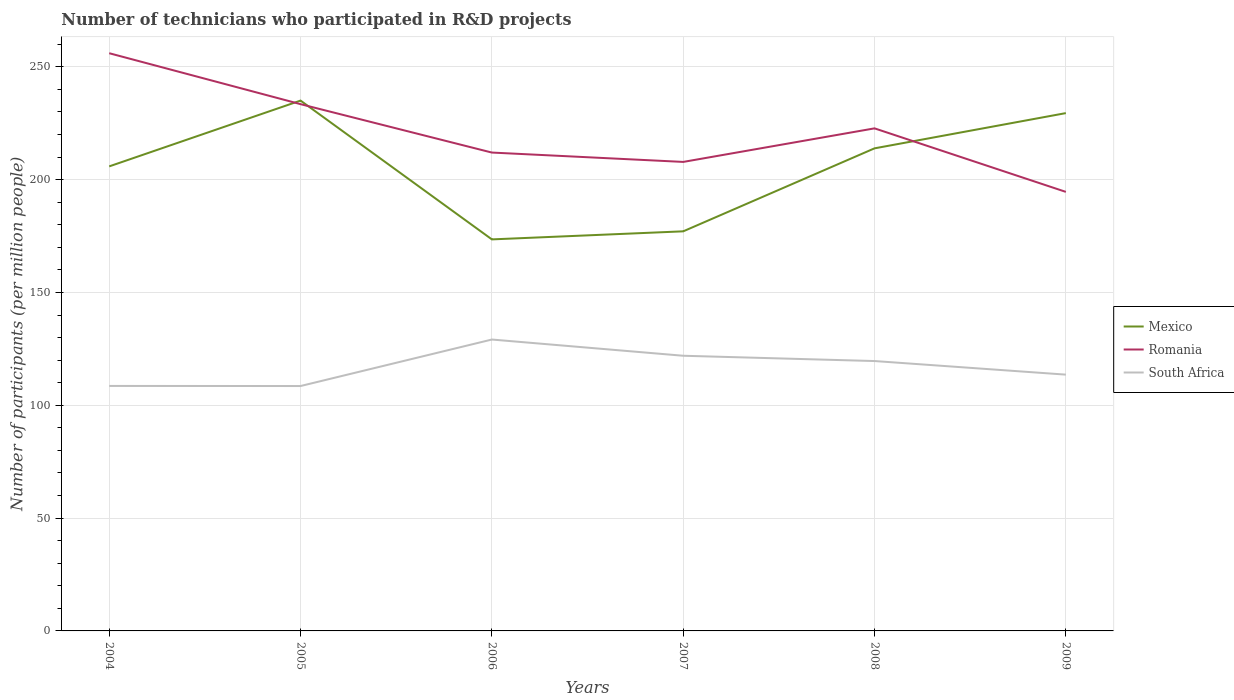Across all years, what is the maximum number of technicians who participated in R&D projects in South Africa?
Provide a succinct answer. 108.54. In which year was the number of technicians who participated in R&D projects in Mexico maximum?
Your answer should be very brief. 2006. What is the total number of technicians who participated in R&D projects in South Africa in the graph?
Provide a short and direct response. -11.07. What is the difference between the highest and the second highest number of technicians who participated in R&D projects in South Africa?
Give a very brief answer. 20.6. What is the difference between the highest and the lowest number of technicians who participated in R&D projects in Romania?
Make the answer very short. 3. How many lines are there?
Give a very brief answer. 3. How many years are there in the graph?
Provide a succinct answer. 6. Are the values on the major ticks of Y-axis written in scientific E-notation?
Provide a succinct answer. No. What is the title of the graph?
Make the answer very short. Number of technicians who participated in R&D projects. What is the label or title of the Y-axis?
Your response must be concise. Number of participants (per million people). What is the Number of participants (per million people) in Mexico in 2004?
Offer a terse response. 205.89. What is the Number of participants (per million people) in Romania in 2004?
Your answer should be very brief. 256.04. What is the Number of participants (per million people) of South Africa in 2004?
Your response must be concise. 108.58. What is the Number of participants (per million people) of Mexico in 2005?
Your response must be concise. 235.05. What is the Number of participants (per million people) of Romania in 2005?
Your answer should be very brief. 233.47. What is the Number of participants (per million people) in South Africa in 2005?
Your response must be concise. 108.54. What is the Number of participants (per million people) of Mexico in 2006?
Your answer should be compact. 173.53. What is the Number of participants (per million people) in Romania in 2006?
Keep it short and to the point. 212.02. What is the Number of participants (per million people) in South Africa in 2006?
Give a very brief answer. 129.14. What is the Number of participants (per million people) of Mexico in 2007?
Provide a succinct answer. 177.1. What is the Number of participants (per million people) in Romania in 2007?
Provide a short and direct response. 207.87. What is the Number of participants (per million people) of South Africa in 2007?
Your answer should be compact. 121.96. What is the Number of participants (per million people) in Mexico in 2008?
Your answer should be compact. 213.89. What is the Number of participants (per million people) of Romania in 2008?
Keep it short and to the point. 222.74. What is the Number of participants (per million people) in South Africa in 2008?
Keep it short and to the point. 119.61. What is the Number of participants (per million people) in Mexico in 2009?
Make the answer very short. 229.5. What is the Number of participants (per million people) in Romania in 2009?
Offer a terse response. 194.59. What is the Number of participants (per million people) of South Africa in 2009?
Give a very brief answer. 113.59. Across all years, what is the maximum Number of participants (per million people) of Mexico?
Offer a terse response. 235.05. Across all years, what is the maximum Number of participants (per million people) in Romania?
Ensure brevity in your answer.  256.04. Across all years, what is the maximum Number of participants (per million people) in South Africa?
Your answer should be very brief. 129.14. Across all years, what is the minimum Number of participants (per million people) of Mexico?
Your response must be concise. 173.53. Across all years, what is the minimum Number of participants (per million people) in Romania?
Your answer should be compact. 194.59. Across all years, what is the minimum Number of participants (per million people) in South Africa?
Offer a very short reply. 108.54. What is the total Number of participants (per million people) in Mexico in the graph?
Your answer should be very brief. 1234.95. What is the total Number of participants (per million people) of Romania in the graph?
Your response must be concise. 1326.72. What is the total Number of participants (per million people) in South Africa in the graph?
Your response must be concise. 701.43. What is the difference between the Number of participants (per million people) in Mexico in 2004 and that in 2005?
Your answer should be compact. -29.16. What is the difference between the Number of participants (per million people) in Romania in 2004 and that in 2005?
Your answer should be very brief. 22.58. What is the difference between the Number of participants (per million people) of South Africa in 2004 and that in 2005?
Keep it short and to the point. 0.04. What is the difference between the Number of participants (per million people) of Mexico in 2004 and that in 2006?
Provide a succinct answer. 32.36. What is the difference between the Number of participants (per million people) of Romania in 2004 and that in 2006?
Your answer should be very brief. 44.03. What is the difference between the Number of participants (per million people) in South Africa in 2004 and that in 2006?
Offer a terse response. -20.56. What is the difference between the Number of participants (per million people) in Mexico in 2004 and that in 2007?
Your response must be concise. 28.79. What is the difference between the Number of participants (per million people) of Romania in 2004 and that in 2007?
Ensure brevity in your answer.  48.18. What is the difference between the Number of participants (per million people) of South Africa in 2004 and that in 2007?
Your response must be concise. -13.38. What is the difference between the Number of participants (per million people) in Mexico in 2004 and that in 2008?
Your response must be concise. -8. What is the difference between the Number of participants (per million people) in Romania in 2004 and that in 2008?
Keep it short and to the point. 33.3. What is the difference between the Number of participants (per million people) of South Africa in 2004 and that in 2008?
Keep it short and to the point. -11.03. What is the difference between the Number of participants (per million people) of Mexico in 2004 and that in 2009?
Give a very brief answer. -23.61. What is the difference between the Number of participants (per million people) in Romania in 2004 and that in 2009?
Provide a succinct answer. 61.46. What is the difference between the Number of participants (per million people) of South Africa in 2004 and that in 2009?
Make the answer very short. -5.01. What is the difference between the Number of participants (per million people) of Mexico in 2005 and that in 2006?
Keep it short and to the point. 61.52. What is the difference between the Number of participants (per million people) of Romania in 2005 and that in 2006?
Offer a terse response. 21.45. What is the difference between the Number of participants (per million people) of South Africa in 2005 and that in 2006?
Ensure brevity in your answer.  -20.6. What is the difference between the Number of participants (per million people) in Mexico in 2005 and that in 2007?
Your response must be concise. 57.95. What is the difference between the Number of participants (per million people) in Romania in 2005 and that in 2007?
Your response must be concise. 25.6. What is the difference between the Number of participants (per million people) of South Africa in 2005 and that in 2007?
Your answer should be very brief. -13.42. What is the difference between the Number of participants (per million people) in Mexico in 2005 and that in 2008?
Offer a terse response. 21.16. What is the difference between the Number of participants (per million people) in Romania in 2005 and that in 2008?
Make the answer very short. 10.73. What is the difference between the Number of participants (per million people) in South Africa in 2005 and that in 2008?
Provide a short and direct response. -11.07. What is the difference between the Number of participants (per million people) of Mexico in 2005 and that in 2009?
Give a very brief answer. 5.55. What is the difference between the Number of participants (per million people) of Romania in 2005 and that in 2009?
Provide a succinct answer. 38.88. What is the difference between the Number of participants (per million people) in South Africa in 2005 and that in 2009?
Provide a succinct answer. -5.05. What is the difference between the Number of participants (per million people) of Mexico in 2006 and that in 2007?
Your answer should be very brief. -3.57. What is the difference between the Number of participants (per million people) in Romania in 2006 and that in 2007?
Provide a succinct answer. 4.15. What is the difference between the Number of participants (per million people) in South Africa in 2006 and that in 2007?
Your answer should be compact. 7.19. What is the difference between the Number of participants (per million people) of Mexico in 2006 and that in 2008?
Offer a terse response. -40.36. What is the difference between the Number of participants (per million people) of Romania in 2006 and that in 2008?
Ensure brevity in your answer.  -10.72. What is the difference between the Number of participants (per million people) in South Africa in 2006 and that in 2008?
Give a very brief answer. 9.53. What is the difference between the Number of participants (per million people) of Mexico in 2006 and that in 2009?
Give a very brief answer. -55.97. What is the difference between the Number of participants (per million people) of Romania in 2006 and that in 2009?
Ensure brevity in your answer.  17.43. What is the difference between the Number of participants (per million people) of South Africa in 2006 and that in 2009?
Offer a terse response. 15.55. What is the difference between the Number of participants (per million people) of Mexico in 2007 and that in 2008?
Your response must be concise. -36.79. What is the difference between the Number of participants (per million people) of Romania in 2007 and that in 2008?
Offer a terse response. -14.87. What is the difference between the Number of participants (per million people) in South Africa in 2007 and that in 2008?
Offer a terse response. 2.34. What is the difference between the Number of participants (per million people) in Mexico in 2007 and that in 2009?
Make the answer very short. -52.4. What is the difference between the Number of participants (per million people) of Romania in 2007 and that in 2009?
Ensure brevity in your answer.  13.28. What is the difference between the Number of participants (per million people) in South Africa in 2007 and that in 2009?
Provide a succinct answer. 8.37. What is the difference between the Number of participants (per million people) of Mexico in 2008 and that in 2009?
Offer a very short reply. -15.61. What is the difference between the Number of participants (per million people) of Romania in 2008 and that in 2009?
Offer a very short reply. 28.15. What is the difference between the Number of participants (per million people) of South Africa in 2008 and that in 2009?
Offer a very short reply. 6.02. What is the difference between the Number of participants (per million people) in Mexico in 2004 and the Number of participants (per million people) in Romania in 2005?
Offer a very short reply. -27.58. What is the difference between the Number of participants (per million people) of Mexico in 2004 and the Number of participants (per million people) of South Africa in 2005?
Give a very brief answer. 97.35. What is the difference between the Number of participants (per million people) of Romania in 2004 and the Number of participants (per million people) of South Africa in 2005?
Keep it short and to the point. 147.5. What is the difference between the Number of participants (per million people) in Mexico in 2004 and the Number of participants (per million people) in Romania in 2006?
Your response must be concise. -6.13. What is the difference between the Number of participants (per million people) in Mexico in 2004 and the Number of participants (per million people) in South Africa in 2006?
Ensure brevity in your answer.  76.74. What is the difference between the Number of participants (per million people) in Romania in 2004 and the Number of participants (per million people) in South Africa in 2006?
Make the answer very short. 126.9. What is the difference between the Number of participants (per million people) of Mexico in 2004 and the Number of participants (per million people) of Romania in 2007?
Keep it short and to the point. -1.98. What is the difference between the Number of participants (per million people) of Mexico in 2004 and the Number of participants (per million people) of South Africa in 2007?
Offer a terse response. 83.93. What is the difference between the Number of participants (per million people) of Romania in 2004 and the Number of participants (per million people) of South Africa in 2007?
Give a very brief answer. 134.09. What is the difference between the Number of participants (per million people) in Mexico in 2004 and the Number of participants (per million people) in Romania in 2008?
Ensure brevity in your answer.  -16.85. What is the difference between the Number of participants (per million people) of Mexico in 2004 and the Number of participants (per million people) of South Africa in 2008?
Offer a terse response. 86.27. What is the difference between the Number of participants (per million people) in Romania in 2004 and the Number of participants (per million people) in South Africa in 2008?
Provide a short and direct response. 136.43. What is the difference between the Number of participants (per million people) of Mexico in 2004 and the Number of participants (per million people) of Romania in 2009?
Offer a very short reply. 11.3. What is the difference between the Number of participants (per million people) of Mexico in 2004 and the Number of participants (per million people) of South Africa in 2009?
Make the answer very short. 92.3. What is the difference between the Number of participants (per million people) in Romania in 2004 and the Number of participants (per million people) in South Africa in 2009?
Ensure brevity in your answer.  142.45. What is the difference between the Number of participants (per million people) in Mexico in 2005 and the Number of participants (per million people) in Romania in 2006?
Provide a short and direct response. 23.03. What is the difference between the Number of participants (per million people) in Mexico in 2005 and the Number of participants (per million people) in South Africa in 2006?
Give a very brief answer. 105.9. What is the difference between the Number of participants (per million people) of Romania in 2005 and the Number of participants (per million people) of South Africa in 2006?
Give a very brief answer. 104.32. What is the difference between the Number of participants (per million people) of Mexico in 2005 and the Number of participants (per million people) of Romania in 2007?
Make the answer very short. 27.18. What is the difference between the Number of participants (per million people) of Mexico in 2005 and the Number of participants (per million people) of South Africa in 2007?
Your answer should be compact. 113.09. What is the difference between the Number of participants (per million people) of Romania in 2005 and the Number of participants (per million people) of South Africa in 2007?
Your answer should be very brief. 111.51. What is the difference between the Number of participants (per million people) of Mexico in 2005 and the Number of participants (per million people) of Romania in 2008?
Provide a short and direct response. 12.31. What is the difference between the Number of participants (per million people) of Mexico in 2005 and the Number of participants (per million people) of South Africa in 2008?
Provide a succinct answer. 115.43. What is the difference between the Number of participants (per million people) in Romania in 2005 and the Number of participants (per million people) in South Africa in 2008?
Your answer should be very brief. 113.85. What is the difference between the Number of participants (per million people) of Mexico in 2005 and the Number of participants (per million people) of Romania in 2009?
Make the answer very short. 40.46. What is the difference between the Number of participants (per million people) of Mexico in 2005 and the Number of participants (per million people) of South Africa in 2009?
Give a very brief answer. 121.46. What is the difference between the Number of participants (per million people) in Romania in 2005 and the Number of participants (per million people) in South Africa in 2009?
Make the answer very short. 119.88. What is the difference between the Number of participants (per million people) of Mexico in 2006 and the Number of participants (per million people) of Romania in 2007?
Keep it short and to the point. -34.34. What is the difference between the Number of participants (per million people) of Mexico in 2006 and the Number of participants (per million people) of South Africa in 2007?
Offer a very short reply. 51.57. What is the difference between the Number of participants (per million people) in Romania in 2006 and the Number of participants (per million people) in South Africa in 2007?
Your answer should be very brief. 90.06. What is the difference between the Number of participants (per million people) of Mexico in 2006 and the Number of participants (per million people) of Romania in 2008?
Make the answer very short. -49.21. What is the difference between the Number of participants (per million people) of Mexico in 2006 and the Number of participants (per million people) of South Africa in 2008?
Ensure brevity in your answer.  53.91. What is the difference between the Number of participants (per million people) of Romania in 2006 and the Number of participants (per million people) of South Africa in 2008?
Your answer should be compact. 92.4. What is the difference between the Number of participants (per million people) in Mexico in 2006 and the Number of participants (per million people) in Romania in 2009?
Offer a terse response. -21.06. What is the difference between the Number of participants (per million people) of Mexico in 2006 and the Number of participants (per million people) of South Africa in 2009?
Make the answer very short. 59.94. What is the difference between the Number of participants (per million people) of Romania in 2006 and the Number of participants (per million people) of South Africa in 2009?
Make the answer very short. 98.43. What is the difference between the Number of participants (per million people) in Mexico in 2007 and the Number of participants (per million people) in Romania in 2008?
Your answer should be compact. -45.64. What is the difference between the Number of participants (per million people) of Mexico in 2007 and the Number of participants (per million people) of South Africa in 2008?
Provide a short and direct response. 57.49. What is the difference between the Number of participants (per million people) in Romania in 2007 and the Number of participants (per million people) in South Africa in 2008?
Offer a very short reply. 88.25. What is the difference between the Number of participants (per million people) in Mexico in 2007 and the Number of participants (per million people) in Romania in 2009?
Provide a succinct answer. -17.49. What is the difference between the Number of participants (per million people) in Mexico in 2007 and the Number of participants (per million people) in South Africa in 2009?
Keep it short and to the point. 63.51. What is the difference between the Number of participants (per million people) of Romania in 2007 and the Number of participants (per million people) of South Africa in 2009?
Provide a succinct answer. 94.28. What is the difference between the Number of participants (per million people) in Mexico in 2008 and the Number of participants (per million people) in Romania in 2009?
Your answer should be very brief. 19.3. What is the difference between the Number of participants (per million people) in Mexico in 2008 and the Number of participants (per million people) in South Africa in 2009?
Give a very brief answer. 100.3. What is the difference between the Number of participants (per million people) in Romania in 2008 and the Number of participants (per million people) in South Africa in 2009?
Make the answer very short. 109.15. What is the average Number of participants (per million people) of Mexico per year?
Give a very brief answer. 205.82. What is the average Number of participants (per million people) in Romania per year?
Make the answer very short. 221.12. What is the average Number of participants (per million people) in South Africa per year?
Offer a very short reply. 116.9. In the year 2004, what is the difference between the Number of participants (per million people) of Mexico and Number of participants (per million people) of Romania?
Your answer should be very brief. -50.16. In the year 2004, what is the difference between the Number of participants (per million people) of Mexico and Number of participants (per million people) of South Africa?
Ensure brevity in your answer.  97.31. In the year 2004, what is the difference between the Number of participants (per million people) of Romania and Number of participants (per million people) of South Africa?
Provide a succinct answer. 147.46. In the year 2005, what is the difference between the Number of participants (per million people) in Mexico and Number of participants (per million people) in Romania?
Your answer should be compact. 1.58. In the year 2005, what is the difference between the Number of participants (per million people) of Mexico and Number of participants (per million people) of South Africa?
Offer a terse response. 126.51. In the year 2005, what is the difference between the Number of participants (per million people) in Romania and Number of participants (per million people) in South Africa?
Provide a short and direct response. 124.93. In the year 2006, what is the difference between the Number of participants (per million people) in Mexico and Number of participants (per million people) in Romania?
Your answer should be very brief. -38.49. In the year 2006, what is the difference between the Number of participants (per million people) of Mexico and Number of participants (per million people) of South Africa?
Ensure brevity in your answer.  44.38. In the year 2006, what is the difference between the Number of participants (per million people) of Romania and Number of participants (per million people) of South Africa?
Provide a short and direct response. 82.87. In the year 2007, what is the difference between the Number of participants (per million people) in Mexico and Number of participants (per million people) in Romania?
Make the answer very short. -30.77. In the year 2007, what is the difference between the Number of participants (per million people) in Mexico and Number of participants (per million people) in South Africa?
Your answer should be very brief. 55.14. In the year 2007, what is the difference between the Number of participants (per million people) in Romania and Number of participants (per million people) in South Africa?
Give a very brief answer. 85.91. In the year 2008, what is the difference between the Number of participants (per million people) in Mexico and Number of participants (per million people) in Romania?
Provide a short and direct response. -8.85. In the year 2008, what is the difference between the Number of participants (per million people) of Mexico and Number of participants (per million people) of South Africa?
Provide a succinct answer. 94.27. In the year 2008, what is the difference between the Number of participants (per million people) in Romania and Number of participants (per million people) in South Africa?
Provide a short and direct response. 103.13. In the year 2009, what is the difference between the Number of participants (per million people) of Mexico and Number of participants (per million people) of Romania?
Provide a succinct answer. 34.91. In the year 2009, what is the difference between the Number of participants (per million people) in Mexico and Number of participants (per million people) in South Africa?
Keep it short and to the point. 115.91. In the year 2009, what is the difference between the Number of participants (per million people) of Romania and Number of participants (per million people) of South Africa?
Provide a succinct answer. 81. What is the ratio of the Number of participants (per million people) of Mexico in 2004 to that in 2005?
Offer a very short reply. 0.88. What is the ratio of the Number of participants (per million people) in Romania in 2004 to that in 2005?
Provide a short and direct response. 1.1. What is the ratio of the Number of participants (per million people) of South Africa in 2004 to that in 2005?
Provide a succinct answer. 1. What is the ratio of the Number of participants (per million people) in Mexico in 2004 to that in 2006?
Offer a terse response. 1.19. What is the ratio of the Number of participants (per million people) of Romania in 2004 to that in 2006?
Provide a succinct answer. 1.21. What is the ratio of the Number of participants (per million people) of South Africa in 2004 to that in 2006?
Give a very brief answer. 0.84. What is the ratio of the Number of participants (per million people) of Mexico in 2004 to that in 2007?
Make the answer very short. 1.16. What is the ratio of the Number of participants (per million people) in Romania in 2004 to that in 2007?
Provide a short and direct response. 1.23. What is the ratio of the Number of participants (per million people) of South Africa in 2004 to that in 2007?
Offer a very short reply. 0.89. What is the ratio of the Number of participants (per million people) of Mexico in 2004 to that in 2008?
Offer a very short reply. 0.96. What is the ratio of the Number of participants (per million people) of Romania in 2004 to that in 2008?
Your response must be concise. 1.15. What is the ratio of the Number of participants (per million people) in South Africa in 2004 to that in 2008?
Your answer should be very brief. 0.91. What is the ratio of the Number of participants (per million people) in Mexico in 2004 to that in 2009?
Your answer should be compact. 0.9. What is the ratio of the Number of participants (per million people) in Romania in 2004 to that in 2009?
Your answer should be compact. 1.32. What is the ratio of the Number of participants (per million people) in South Africa in 2004 to that in 2009?
Your answer should be compact. 0.96. What is the ratio of the Number of participants (per million people) in Mexico in 2005 to that in 2006?
Your answer should be very brief. 1.35. What is the ratio of the Number of participants (per million people) of Romania in 2005 to that in 2006?
Ensure brevity in your answer.  1.1. What is the ratio of the Number of participants (per million people) in South Africa in 2005 to that in 2006?
Provide a short and direct response. 0.84. What is the ratio of the Number of participants (per million people) in Mexico in 2005 to that in 2007?
Make the answer very short. 1.33. What is the ratio of the Number of participants (per million people) of Romania in 2005 to that in 2007?
Your answer should be very brief. 1.12. What is the ratio of the Number of participants (per million people) in South Africa in 2005 to that in 2007?
Offer a very short reply. 0.89. What is the ratio of the Number of participants (per million people) of Mexico in 2005 to that in 2008?
Offer a terse response. 1.1. What is the ratio of the Number of participants (per million people) of Romania in 2005 to that in 2008?
Give a very brief answer. 1.05. What is the ratio of the Number of participants (per million people) of South Africa in 2005 to that in 2008?
Keep it short and to the point. 0.91. What is the ratio of the Number of participants (per million people) in Mexico in 2005 to that in 2009?
Your answer should be compact. 1.02. What is the ratio of the Number of participants (per million people) in Romania in 2005 to that in 2009?
Provide a short and direct response. 1.2. What is the ratio of the Number of participants (per million people) in South Africa in 2005 to that in 2009?
Offer a very short reply. 0.96. What is the ratio of the Number of participants (per million people) in Mexico in 2006 to that in 2007?
Make the answer very short. 0.98. What is the ratio of the Number of participants (per million people) of South Africa in 2006 to that in 2007?
Ensure brevity in your answer.  1.06. What is the ratio of the Number of participants (per million people) of Mexico in 2006 to that in 2008?
Keep it short and to the point. 0.81. What is the ratio of the Number of participants (per million people) of Romania in 2006 to that in 2008?
Your response must be concise. 0.95. What is the ratio of the Number of participants (per million people) of South Africa in 2006 to that in 2008?
Provide a succinct answer. 1.08. What is the ratio of the Number of participants (per million people) in Mexico in 2006 to that in 2009?
Offer a terse response. 0.76. What is the ratio of the Number of participants (per million people) of Romania in 2006 to that in 2009?
Keep it short and to the point. 1.09. What is the ratio of the Number of participants (per million people) of South Africa in 2006 to that in 2009?
Provide a succinct answer. 1.14. What is the ratio of the Number of participants (per million people) in Mexico in 2007 to that in 2008?
Your answer should be compact. 0.83. What is the ratio of the Number of participants (per million people) of Romania in 2007 to that in 2008?
Give a very brief answer. 0.93. What is the ratio of the Number of participants (per million people) in South Africa in 2007 to that in 2008?
Make the answer very short. 1.02. What is the ratio of the Number of participants (per million people) in Mexico in 2007 to that in 2009?
Offer a terse response. 0.77. What is the ratio of the Number of participants (per million people) in Romania in 2007 to that in 2009?
Provide a succinct answer. 1.07. What is the ratio of the Number of participants (per million people) of South Africa in 2007 to that in 2009?
Offer a very short reply. 1.07. What is the ratio of the Number of participants (per million people) in Mexico in 2008 to that in 2009?
Keep it short and to the point. 0.93. What is the ratio of the Number of participants (per million people) of Romania in 2008 to that in 2009?
Keep it short and to the point. 1.14. What is the ratio of the Number of participants (per million people) in South Africa in 2008 to that in 2009?
Offer a very short reply. 1.05. What is the difference between the highest and the second highest Number of participants (per million people) of Mexico?
Your answer should be very brief. 5.55. What is the difference between the highest and the second highest Number of participants (per million people) of Romania?
Provide a short and direct response. 22.58. What is the difference between the highest and the second highest Number of participants (per million people) in South Africa?
Your answer should be very brief. 7.19. What is the difference between the highest and the lowest Number of participants (per million people) of Mexico?
Offer a very short reply. 61.52. What is the difference between the highest and the lowest Number of participants (per million people) of Romania?
Offer a very short reply. 61.46. What is the difference between the highest and the lowest Number of participants (per million people) of South Africa?
Make the answer very short. 20.6. 